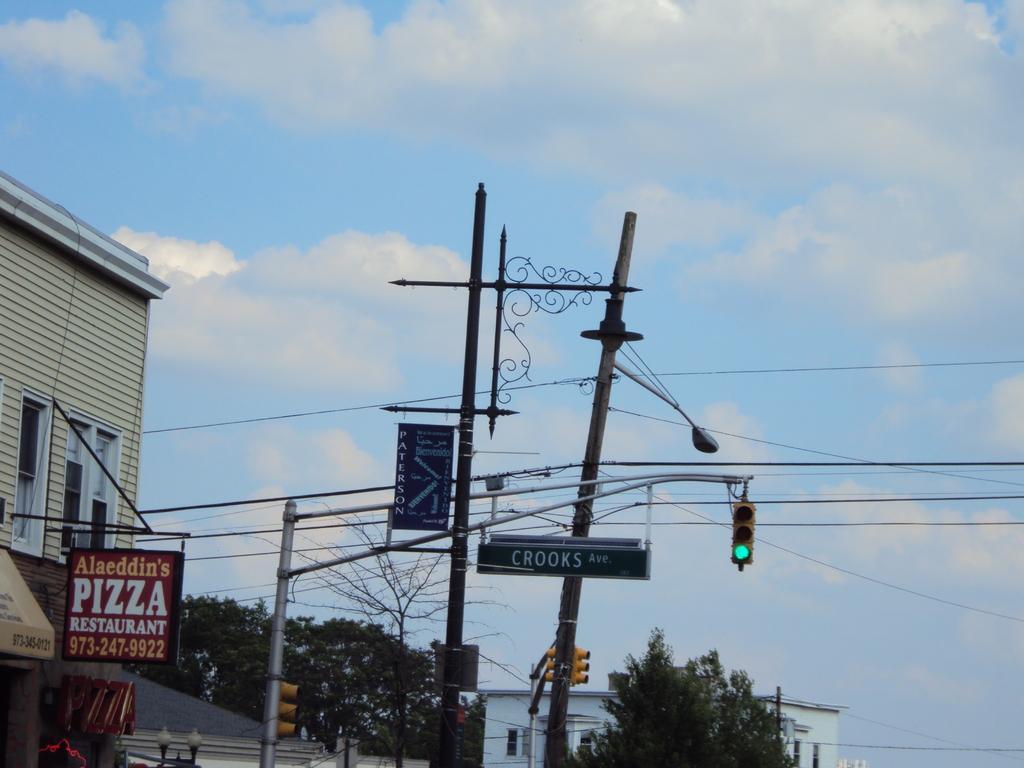Could you give a brief overview of what you see in this image? In this picture we can see buildings, poles, wires, trees, lights, traffic signals and boards. In the background of the image we can see the sky. 